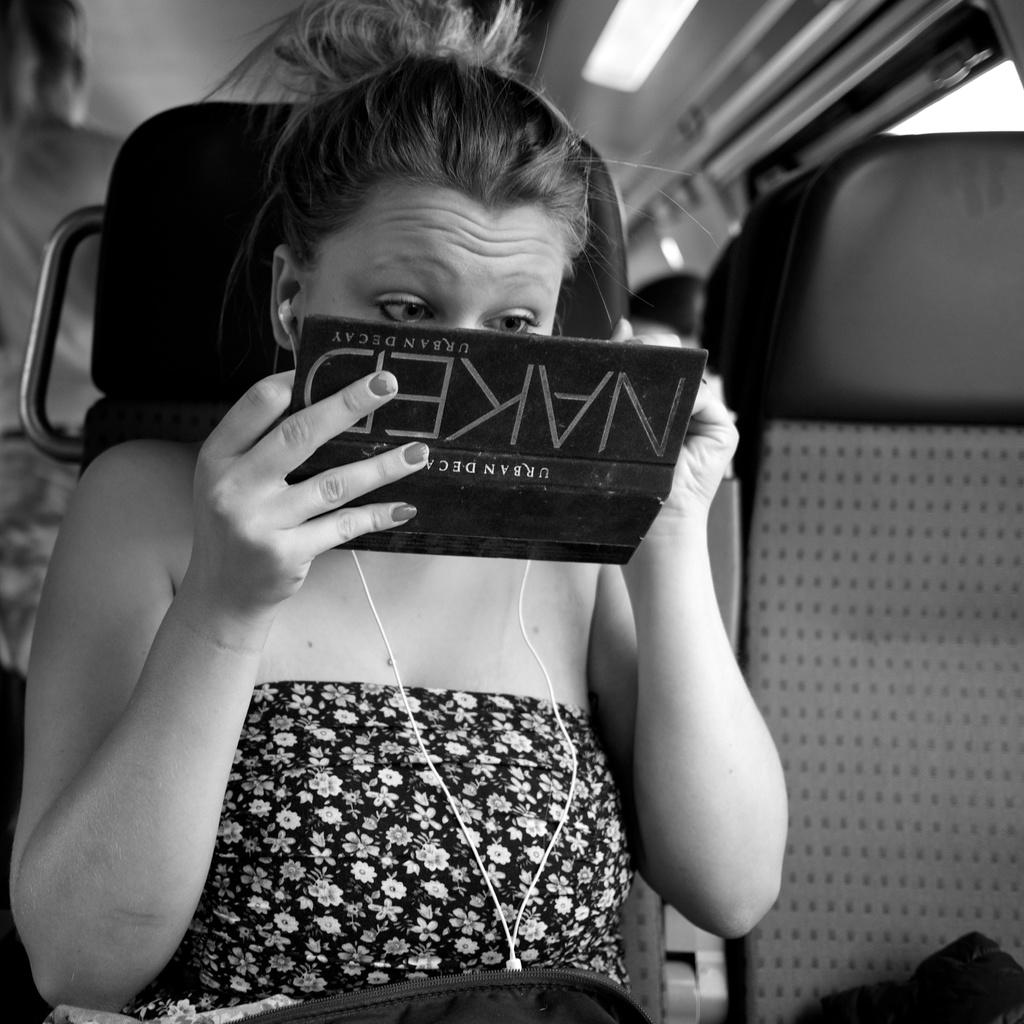Who is the main subject in the image? There is a woman in the image. What is the woman holding in the image? The woman is holding a black object. What is the woman's focus in the image? The woman is looking towards the object she is holding. What is the woman's position in the image? The woman is sitting on a seat. Are there any other seats visible in the image? Yes, there are other seats in the image. Are there any other people in the image? Yes, there are people in the image. What type of lunchroom is visible in the image? There is no lunchroom present in the image. What does the woman's mom say about the cup in the image? There is no cup or mom present in the image. 